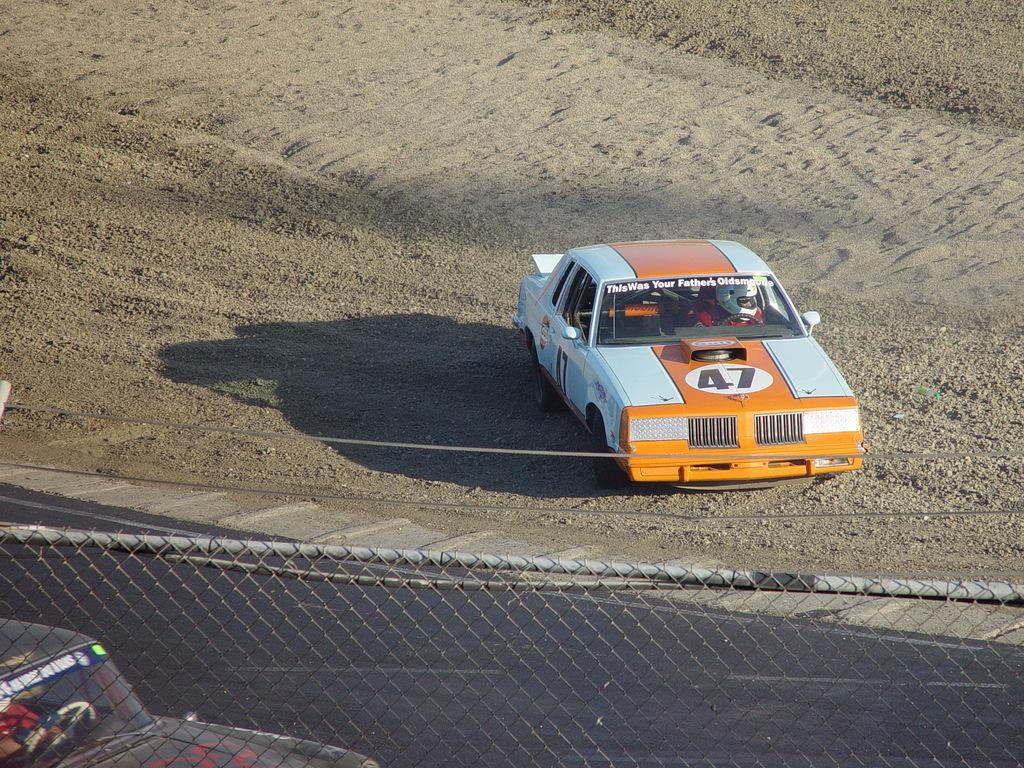How many cars are present in the image? There are two cars in the image. Are there any passengers in the cars? Yes, there are people in the cars. What can be seen on the surface of the cars? There is text on both cars. What type of surface can be seen in the image? There is a road in the image. What is the purpose of the barrier in the image? There is a fence in the image, which may serve as a barrier or boundary. What type of bead is being used for the dinner in the image? There is no bead or dinner present in the image; it features two cars with people inside and a road with a fence. 